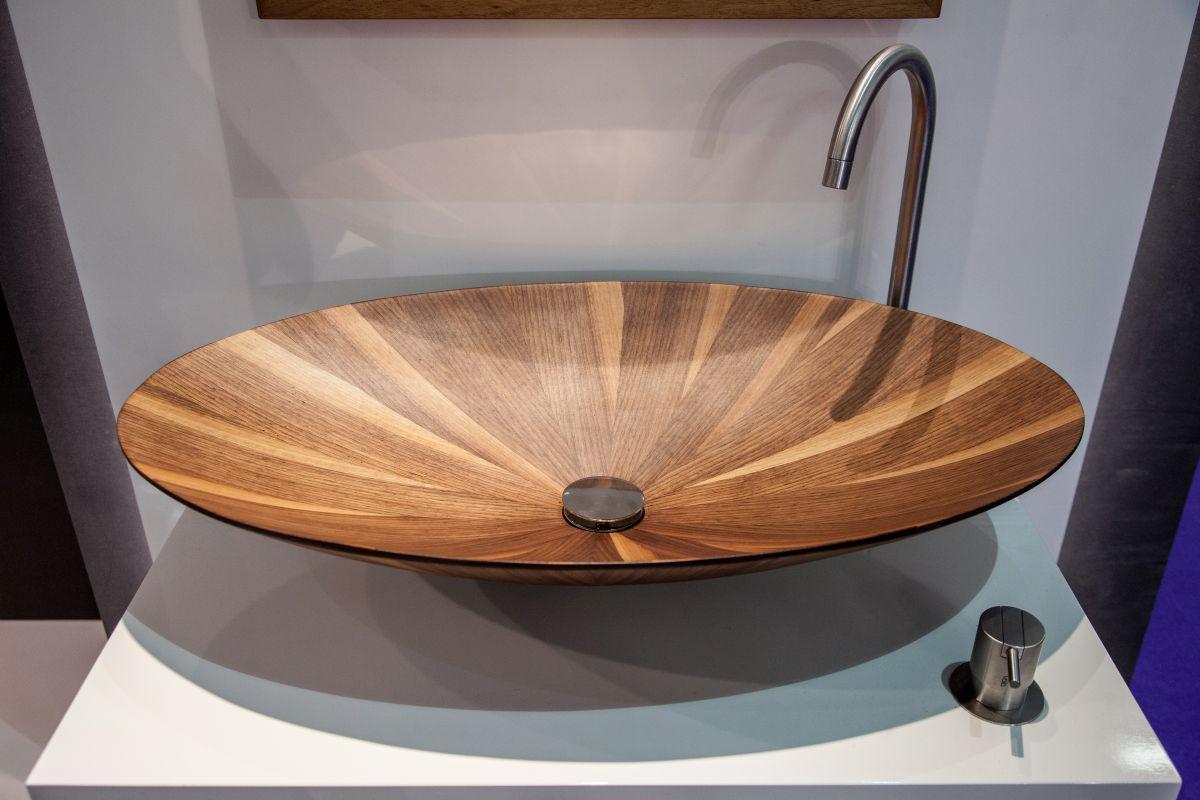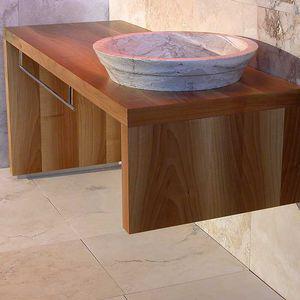The first image is the image on the left, the second image is the image on the right. For the images displayed, is the sentence "One of the images shows a basin with no faucet." factually correct? Answer yes or no. Yes. The first image is the image on the left, the second image is the image on the right. For the images displayed, is the sentence "Photo contains single white sink." factually correct? Answer yes or no. No. 